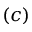<formula> <loc_0><loc_0><loc_500><loc_500>( c )</formula> 